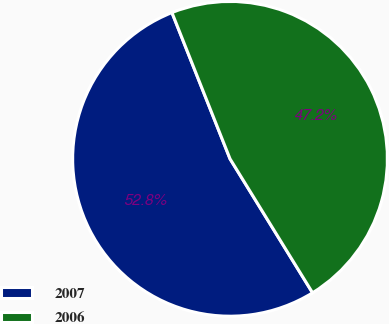<chart> <loc_0><loc_0><loc_500><loc_500><pie_chart><fcel>2007<fcel>2006<nl><fcel>52.77%<fcel>47.23%<nl></chart> 